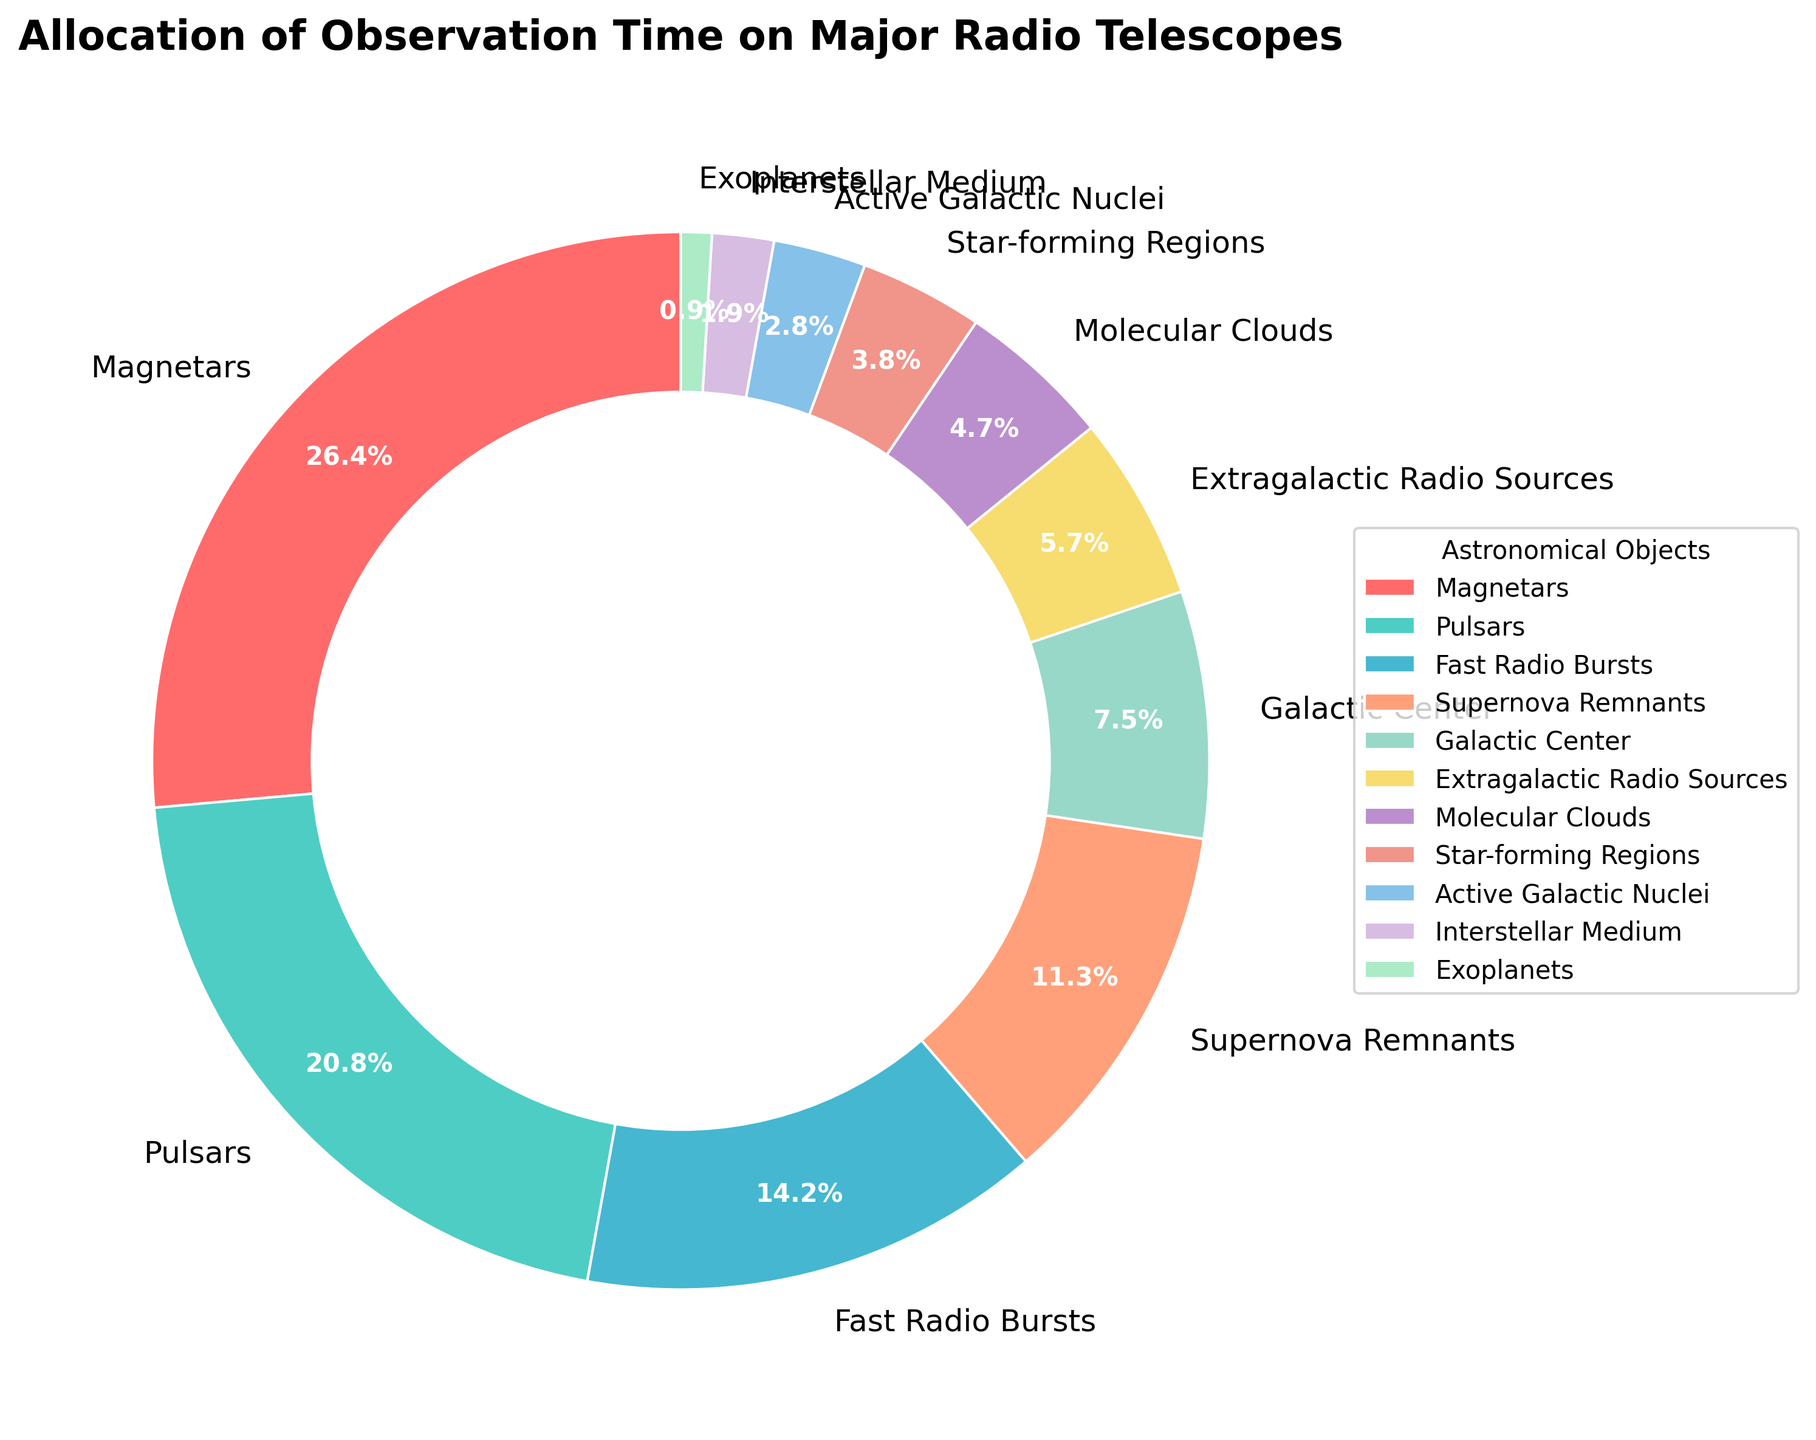What percentage of observation time is allocated to objects other than Magnetars and Pulsars? To find the percentage of observation time allocated to objects other than Magnetars and Pulsars, we first add the percentages for Magnetars and Pulsars (28% + 22% = 50%). Then, we subtract this from 100%: 100% - 50% = 50%.
Answer: 50% Which astronomical object receives the least observation time? By looking at the pie chart, we can see the smallest section representing the astronomical object with the least observation time. It is indicated by the smallest wedge of 1%. This represents Exoplanets.
Answer: Exoplanets How much more observation time is allocated to Magnetars than to the Galactic Center? The chart shows that Magnetars get 28% and the Galactic Center gets 8%. The difference is calculated as 28% - 8% = 20%.
Answer: 20% Combine the observation times allocated to Supernova Remnants and Fast Radio Bursts. How does this sum compare to the observation time allocated to Magnetars? Supernova Remnants have 12%, and Fast Radio Bursts have 15%. Adding them together gives us 12% + 15% = 27%. Magnetars alone have 28%. So, 27% is 1% less than 28%.
Answer: 1% less Which objects receive the second and third highest percentages of observation time? Magnetars have the highest percentage at 28%. Pulsars follow with 22%, and Fast Radio Bursts come next with 15%. Thus, the second highest is Pulsars, and the third is Fast Radio Bursts.
Answer: Pulsars and Fast Radio Bursts How much total observation time is allocated to objects related to stars (Pulsars, Supernova Remnants, Star-forming Regions, Magnetars)? Add up the percentages: Magnetars (28%) + Pulsars (22%) + Supernova Remnants (12%) + Star-forming Regions (4%) = 28% + 22% + 12% + 4% = 66%.
Answer: 66% What percentage of observation time is given to Galactic Center and Extragalactic Radio Sources combined? The chart shows 8% for the Galactic Center and 6% for Extragalactic Radio Sources. Together, they sum up to 8% + 6% = 14%.
Answer: 14% How does the allocated observation time for Molecular Clouds compare to that for Active Galactic Nuclei? Molecular Clouds receive 5% of the observation time, while Active Galactic Nuclei receive 3%. Therefore, Molecular Clouds get 2% more time than Active Galactic Nuclei.
Answer: 2% more What is the visual representation color of the galaxy segment with the highest allocation? The object with the highest allocation is Magnetars (28%). The color associated with Magnetars in the pie chart is red.
Answer: Red 